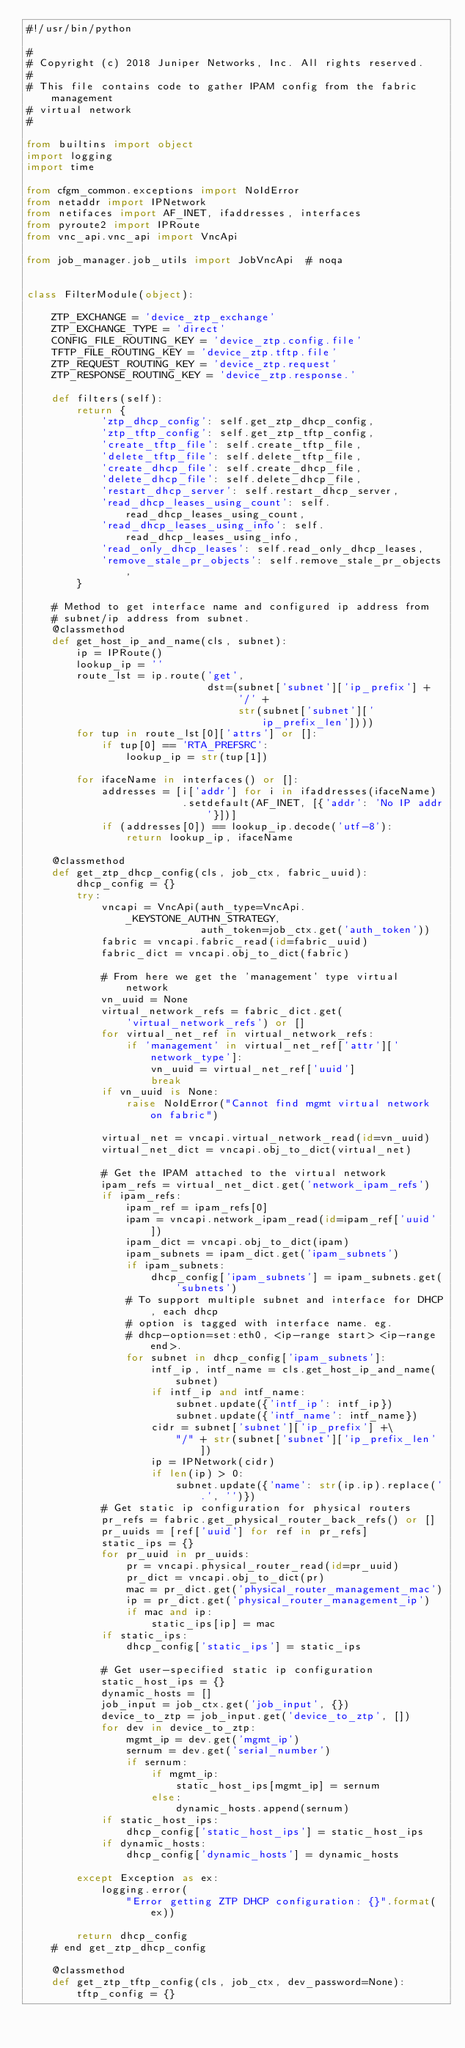<code> <loc_0><loc_0><loc_500><loc_500><_Python_>#!/usr/bin/python

#
# Copyright (c) 2018 Juniper Networks, Inc. All rights reserved.
#
# This file contains code to gather IPAM config from the fabric management
# virtual network
#

from builtins import object
import logging
import time

from cfgm_common.exceptions import NoIdError
from netaddr import IPNetwork
from netifaces import AF_INET, ifaddresses, interfaces
from pyroute2 import IPRoute
from vnc_api.vnc_api import VncApi

from job_manager.job_utils import JobVncApi  # noqa


class FilterModule(object):

    ZTP_EXCHANGE = 'device_ztp_exchange'
    ZTP_EXCHANGE_TYPE = 'direct'
    CONFIG_FILE_ROUTING_KEY = 'device_ztp.config.file'
    TFTP_FILE_ROUTING_KEY = 'device_ztp.tftp.file'
    ZTP_REQUEST_ROUTING_KEY = 'device_ztp.request'
    ZTP_RESPONSE_ROUTING_KEY = 'device_ztp.response.'

    def filters(self):
        return {
            'ztp_dhcp_config': self.get_ztp_dhcp_config,
            'ztp_tftp_config': self.get_ztp_tftp_config,
            'create_tftp_file': self.create_tftp_file,
            'delete_tftp_file': self.delete_tftp_file,
            'create_dhcp_file': self.create_dhcp_file,
            'delete_dhcp_file': self.delete_dhcp_file,
            'restart_dhcp_server': self.restart_dhcp_server,
            'read_dhcp_leases_using_count': self.read_dhcp_leases_using_count,
            'read_dhcp_leases_using_info': self.read_dhcp_leases_using_info,
            'read_only_dhcp_leases': self.read_only_dhcp_leases,
            'remove_stale_pr_objects': self.remove_stale_pr_objects,
        }

    # Method to get interface name and configured ip address from
    # subnet/ip address from subnet.
    @classmethod
    def get_host_ip_and_name(cls, subnet):
        ip = IPRoute()
        lookup_ip = ''
        route_lst = ip.route('get',
                             dst=(subnet['subnet']['ip_prefix'] +
                                  '/' +
                                  str(subnet['subnet']['ip_prefix_len'])))
        for tup in route_lst[0]['attrs'] or []:
            if tup[0] == 'RTA_PREFSRC':
                lookup_ip = str(tup[1])

        for ifaceName in interfaces() or []:
            addresses = [i['addr'] for i in ifaddresses(ifaceName)
                         .setdefault(AF_INET, [{'addr': 'No IP addr'}])]
            if (addresses[0]) == lookup_ip.decode('utf-8'):
                return lookup_ip, ifaceName

    @classmethod
    def get_ztp_dhcp_config(cls, job_ctx, fabric_uuid):
        dhcp_config = {}
        try:
            vncapi = VncApi(auth_type=VncApi._KEYSTONE_AUTHN_STRATEGY,
                            auth_token=job_ctx.get('auth_token'))
            fabric = vncapi.fabric_read(id=fabric_uuid)
            fabric_dict = vncapi.obj_to_dict(fabric)

            # From here we get the 'management' type virtual network
            vn_uuid = None
            virtual_network_refs = fabric_dict.get(
                'virtual_network_refs') or []
            for virtual_net_ref in virtual_network_refs:
                if 'management' in virtual_net_ref['attr']['network_type']:
                    vn_uuid = virtual_net_ref['uuid']
                    break
            if vn_uuid is None:
                raise NoIdError("Cannot find mgmt virtual network on fabric")

            virtual_net = vncapi.virtual_network_read(id=vn_uuid)
            virtual_net_dict = vncapi.obj_to_dict(virtual_net)

            # Get the IPAM attached to the virtual network
            ipam_refs = virtual_net_dict.get('network_ipam_refs')
            if ipam_refs:
                ipam_ref = ipam_refs[0]
                ipam = vncapi.network_ipam_read(id=ipam_ref['uuid'])
                ipam_dict = vncapi.obj_to_dict(ipam)
                ipam_subnets = ipam_dict.get('ipam_subnets')
                if ipam_subnets:
                    dhcp_config['ipam_subnets'] = ipam_subnets.get('subnets')
                # To support multiple subnet and interface for DHCP, each dhcp
                # option is tagged with interface name. eg.
                # dhcp-option=set:eth0, <ip-range start> <ip-range end>.
                for subnet in dhcp_config['ipam_subnets']:
                    intf_ip, intf_name = cls.get_host_ip_and_name(subnet)
                    if intf_ip and intf_name:
                        subnet.update({'intf_ip': intf_ip})
                        subnet.update({'intf_name': intf_name})
                    cidr = subnet['subnet']['ip_prefix'] +\
                        "/" + str(subnet['subnet']['ip_prefix_len'])
                    ip = IPNetwork(cidr)
                    if len(ip) > 0:
                        subnet.update({'name': str(ip.ip).replace('.', '')})
            # Get static ip configuration for physical routers
            pr_refs = fabric.get_physical_router_back_refs() or []
            pr_uuids = [ref['uuid'] for ref in pr_refs]
            static_ips = {}
            for pr_uuid in pr_uuids:
                pr = vncapi.physical_router_read(id=pr_uuid)
                pr_dict = vncapi.obj_to_dict(pr)
                mac = pr_dict.get('physical_router_management_mac')
                ip = pr_dict.get('physical_router_management_ip')
                if mac and ip:
                    static_ips[ip] = mac
            if static_ips:
                dhcp_config['static_ips'] = static_ips

            # Get user-specified static ip configuration
            static_host_ips = {}
            dynamic_hosts = []
            job_input = job_ctx.get('job_input', {})
            device_to_ztp = job_input.get('device_to_ztp', [])
            for dev in device_to_ztp:
                mgmt_ip = dev.get('mgmt_ip')
                sernum = dev.get('serial_number')
                if sernum:
                    if mgmt_ip:
                        static_host_ips[mgmt_ip] = sernum
                    else:
                        dynamic_hosts.append(sernum)
            if static_host_ips:
                dhcp_config['static_host_ips'] = static_host_ips
            if dynamic_hosts:
                dhcp_config['dynamic_hosts'] = dynamic_hosts

        except Exception as ex:
            logging.error(
                "Error getting ZTP DHCP configuration: {}".format(ex))

        return dhcp_config
    # end get_ztp_dhcp_config

    @classmethod
    def get_ztp_tftp_config(cls, job_ctx, dev_password=None):
        tftp_config = {}</code> 